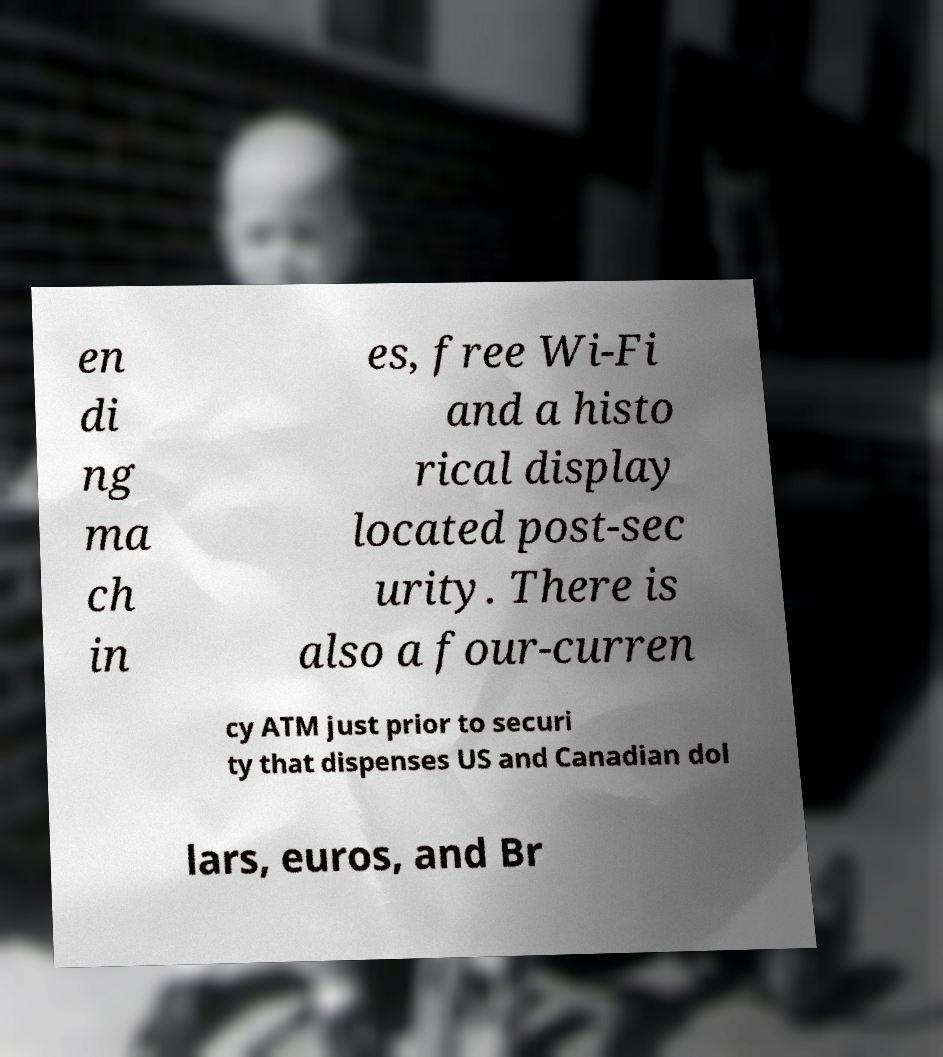What messages or text are displayed in this image? I need them in a readable, typed format. en di ng ma ch in es, free Wi-Fi and a histo rical display located post-sec urity. There is also a four-curren cy ATM just prior to securi ty that dispenses US and Canadian dol lars, euros, and Br 